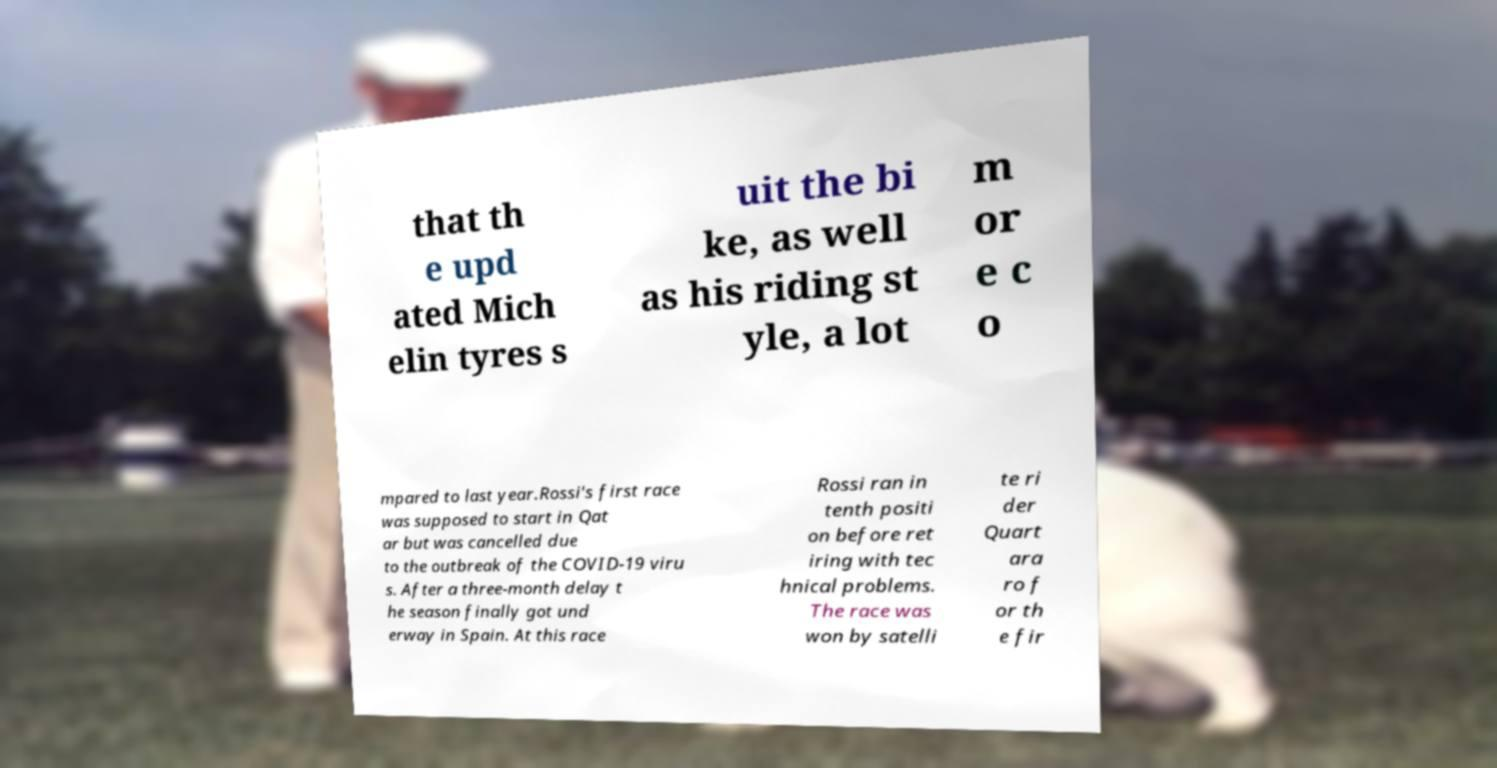I need the written content from this picture converted into text. Can you do that? that th e upd ated Mich elin tyres s uit the bi ke, as well as his riding st yle, a lot m or e c o mpared to last year.Rossi's first race was supposed to start in Qat ar but was cancelled due to the outbreak of the COVID-19 viru s. After a three-month delay t he season finally got und erway in Spain. At this race Rossi ran in tenth positi on before ret iring with tec hnical problems. The race was won by satelli te ri der Quart ara ro f or th e fir 